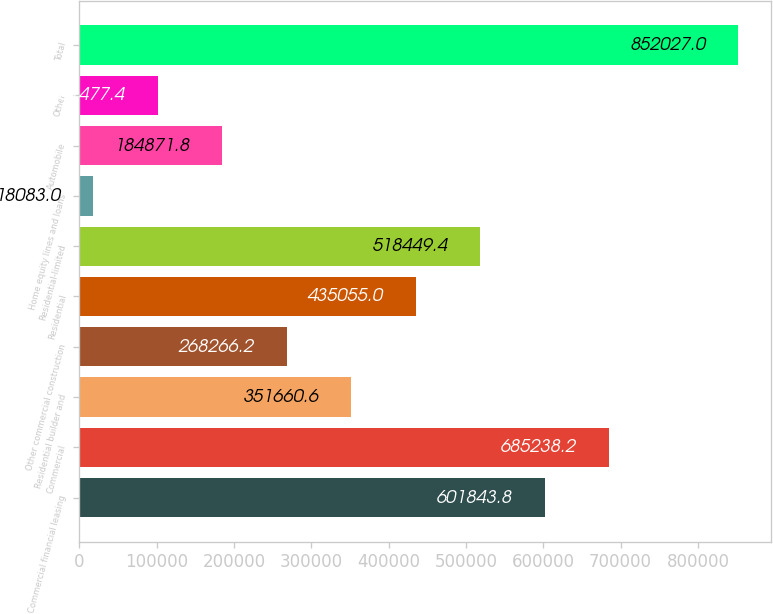Convert chart to OTSL. <chart><loc_0><loc_0><loc_500><loc_500><bar_chart><fcel>Commercial financial leasing<fcel>Commercial<fcel>Residential builder and<fcel>Other commercial construction<fcel>Residential<fcel>Residential-limited<fcel>Home equity lines and loans<fcel>Automobile<fcel>Other<fcel>Total<nl><fcel>601844<fcel>685238<fcel>351661<fcel>268266<fcel>435055<fcel>518449<fcel>18083<fcel>184872<fcel>101477<fcel>852027<nl></chart> 